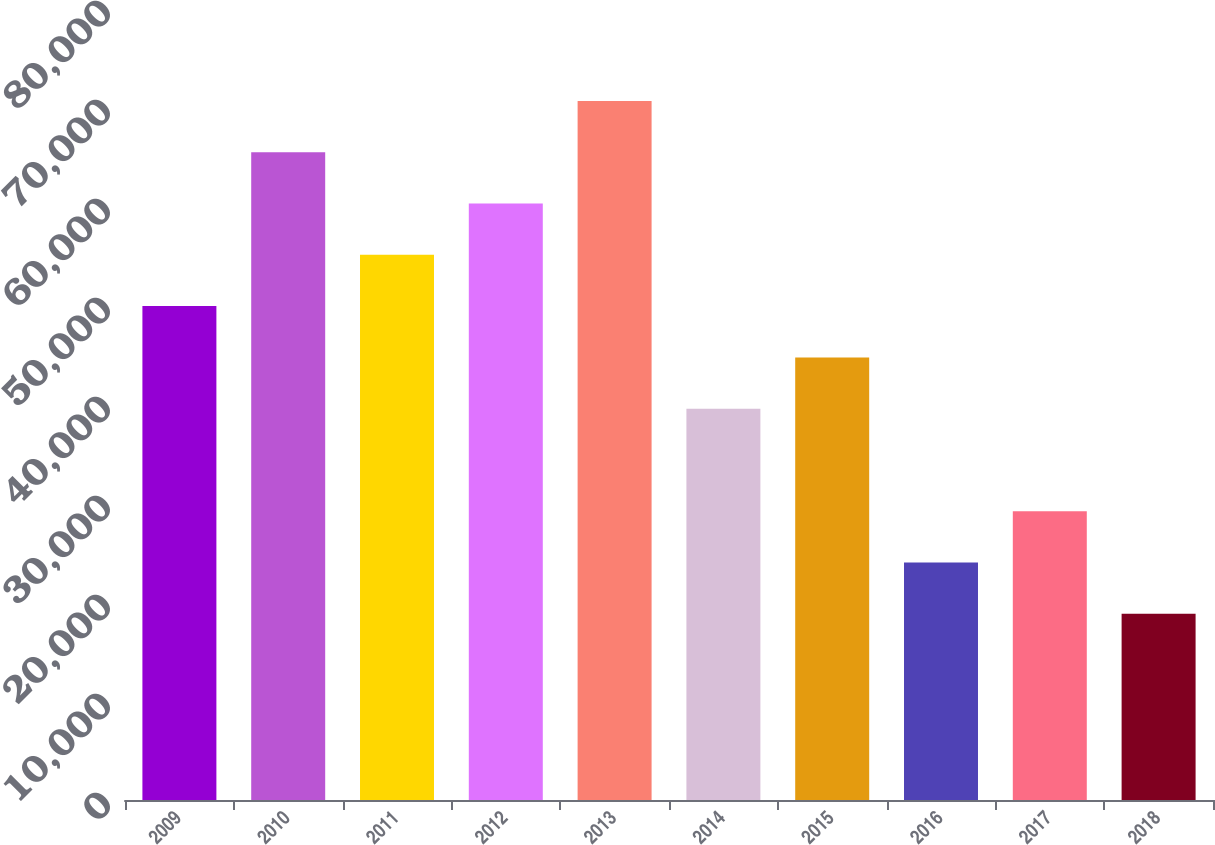Convert chart. <chart><loc_0><loc_0><loc_500><loc_500><bar_chart><fcel>2009<fcel>2010<fcel>2011<fcel>2012<fcel>2013<fcel>2014<fcel>2015<fcel>2016<fcel>2017<fcel>2018<nl><fcel>49886.6<fcel>65422.4<fcel>55065.2<fcel>60243.8<fcel>70601<fcel>39529.4<fcel>44708<fcel>23993.6<fcel>29172.2<fcel>18815<nl></chart> 